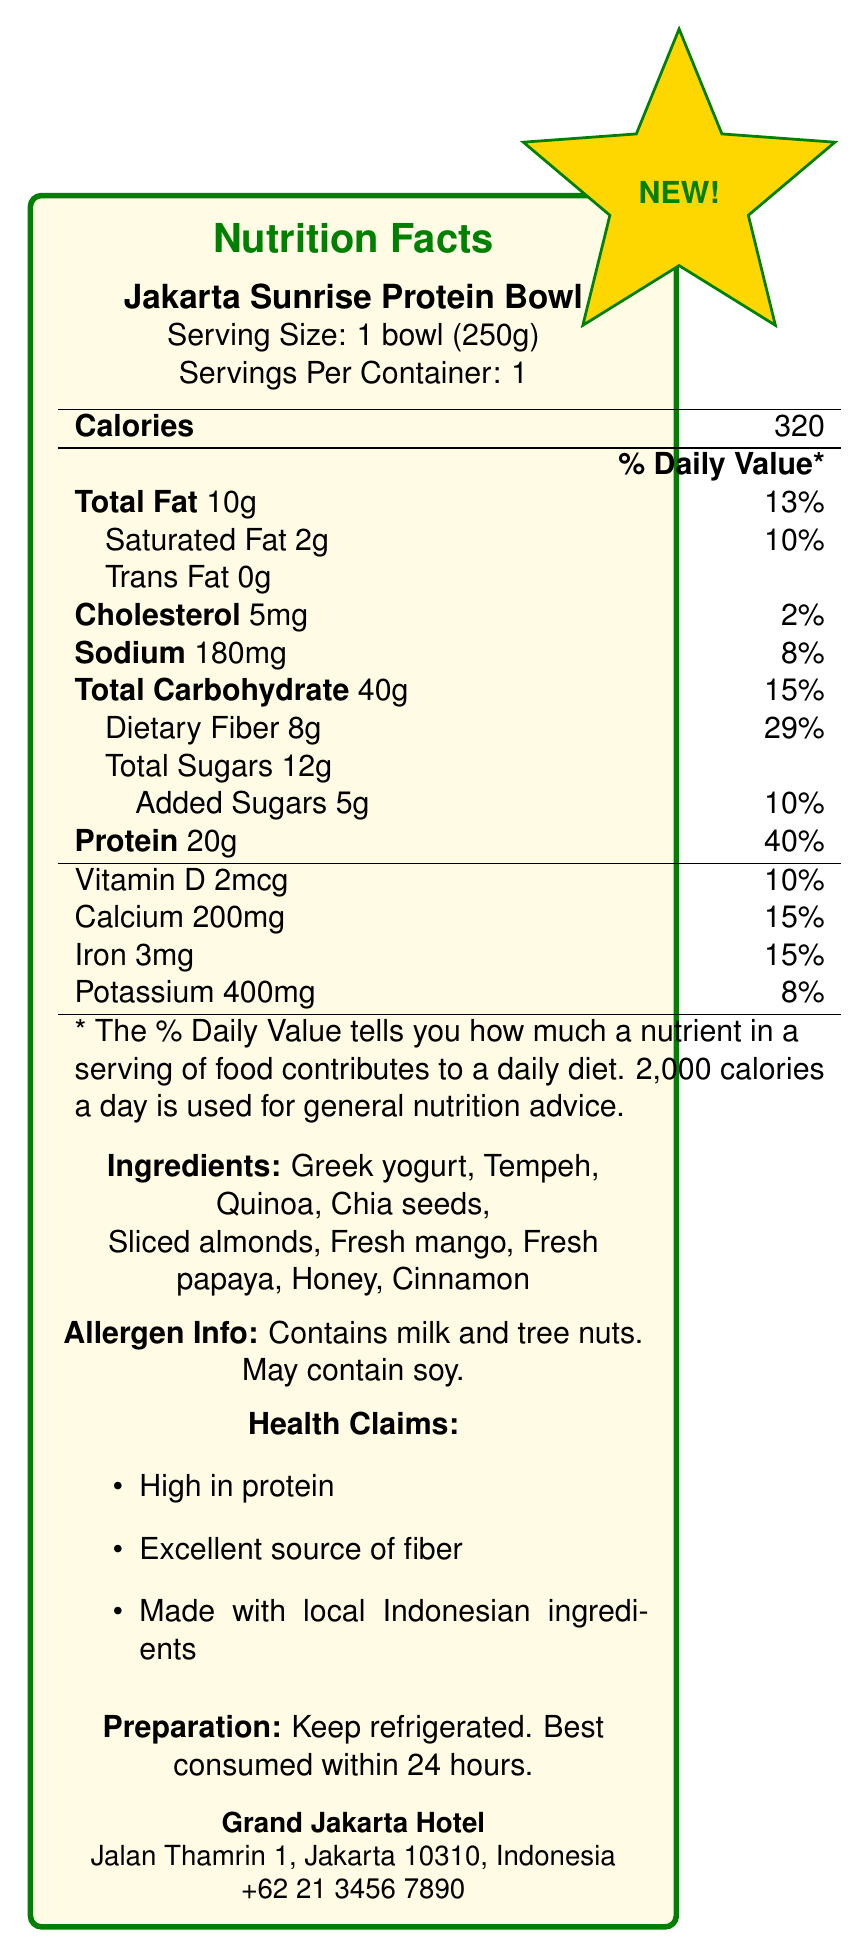what is the serving size for the Jakarta Sunrise Protein Bowl? The serving size is specified as "1 bowl (250g)" in the document.
Answer: 1 bowl (250g) how many calories are in one serving of the Jakarta Sunrise Protein Bowl? The calories per serving are stated as 320 in the Nutrition Facts section.
Answer: 320 what is the total carbohydrate content in the Jakarta Sunrise Protein Bowl? The document specifies the total carbohydrate content as 40g.
Answer: 40g how much dietary fiber does the Jakarta Sunrise Protein Bowl contain? The dietary fiber content is listed as 8g in the document.
Answer: 8g what percent of the daily value of protein does the Jakarta Sunrise Protein Bowl provide? The document states that the Jakarta Sunrise Protein Bowl provides 40% of the daily value of protein.
Answer: 40% which of the following ingredients are included in the Jakarta Sunrise Protein Bowl? A. Peanut Butter, B. Greek yogurt, C. Raisins, D. Blueberries Greek yogurt is listed as one of the ingredients in the document.
Answer: B how much added sugars are there in the Jakarta Sunrise Protein Bowl? A. 12g, B. 5g, C. 3g, D. 8g The amount of added sugars is stated as 5g in the document.
Answer: B does the Jakarta Sunrise Protein Bowl contain soy? According to the allergen information, the bowl "May contain soy."
Answer: May contain soy what health claims are made about the Jakarta Sunrise Protein Bowl? The document lists these three health claims.
Answer: High in protein, Excellent source of fiber, Made with local Indonesian ingredients does the Jakarta Sunrise Protein Bowl need to be refrigerated? The preparation instructions indicate that the bowl should be kept refrigerated.
Answer: Yes summarize the main idea of the document. The document offers a comprehensive overview of the new healthy breakfast option, emphasizing its nutritional benefits and local ingredients.
Answer: The document provides detailed nutritional information about the Jakarta Sunrise Protein Bowl, highlighting its high protein and fiber content, ingredients, allergen info, preparation instructions, and health claims. how much calcium is in one serving of the Jakarta Sunrise Protein Bowl? The amount of calcium is listed as 200mg in the document.
Answer: 200mg where is Grand Jakarta Hotel located? The hotel's address is provided in the hotel information section of the document.
Answer: Jalan Thamrin 1, Jakarta 10310, Indonesia how much saturated fat is in one serving of the Jakarta Sunrise Protein Bowl? The document lists the saturated fat content as 2g.
Answer: 2g which nutrient has the highest percent daily value in the Jakarta Sunrise Protein Bowl? Protein has the highest percent daily value at 40%.
Answer: Protein what is the daily value percentage for dietary fiber in the Jakarta Sunrise Protein Bowl? The dietary fiber percentage of the daily value is stated to be 29% in the document.
Answer: 29% Contact details of the company manufacturing Jakarta Sunrise Protein Bowl The document provides contact details for Grand Jakarta Hotel, not the company manufacturing the product.
Answer: Not enough information 